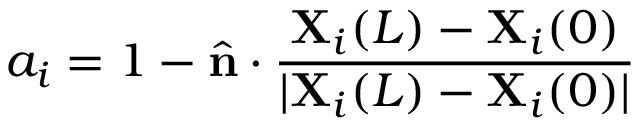<formula> <loc_0><loc_0><loc_500><loc_500>a _ { i } = 1 - \hat { \mathbf n } \cdot \frac { \mathbf X _ { i } ( L ) - \mathbf X _ { i } ( 0 ) } { | \mathbf X _ { i } ( L ) - \mathbf X _ { i } ( 0 ) | }</formula> 